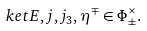<formula> <loc_0><loc_0><loc_500><loc_500>\ k e t { E , j , j _ { 3 } , \eta ^ { \mp } } \in \Phi ^ { \times } _ { \pm } .</formula> 